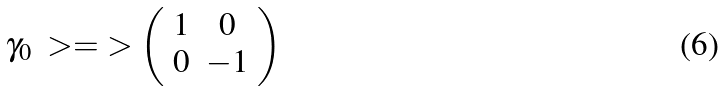<formula> <loc_0><loc_0><loc_500><loc_500>\gamma _ { 0 } \ > = \ > \left ( \begin{array} { c c } 1 & 0 \\ 0 & - 1 \end{array} \right )</formula> 